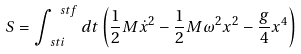<formula> <loc_0><loc_0><loc_500><loc_500>S = \int ^ { \ s t f } _ { \ s t i } d t \left ( \frac { 1 } { 2 } M \dot { x } ^ { 2 } - \frac { 1 } { 2 } M \omega ^ { 2 } x ^ { 2 } - \frac { g } { 4 } x ^ { 4 } \right )</formula> 